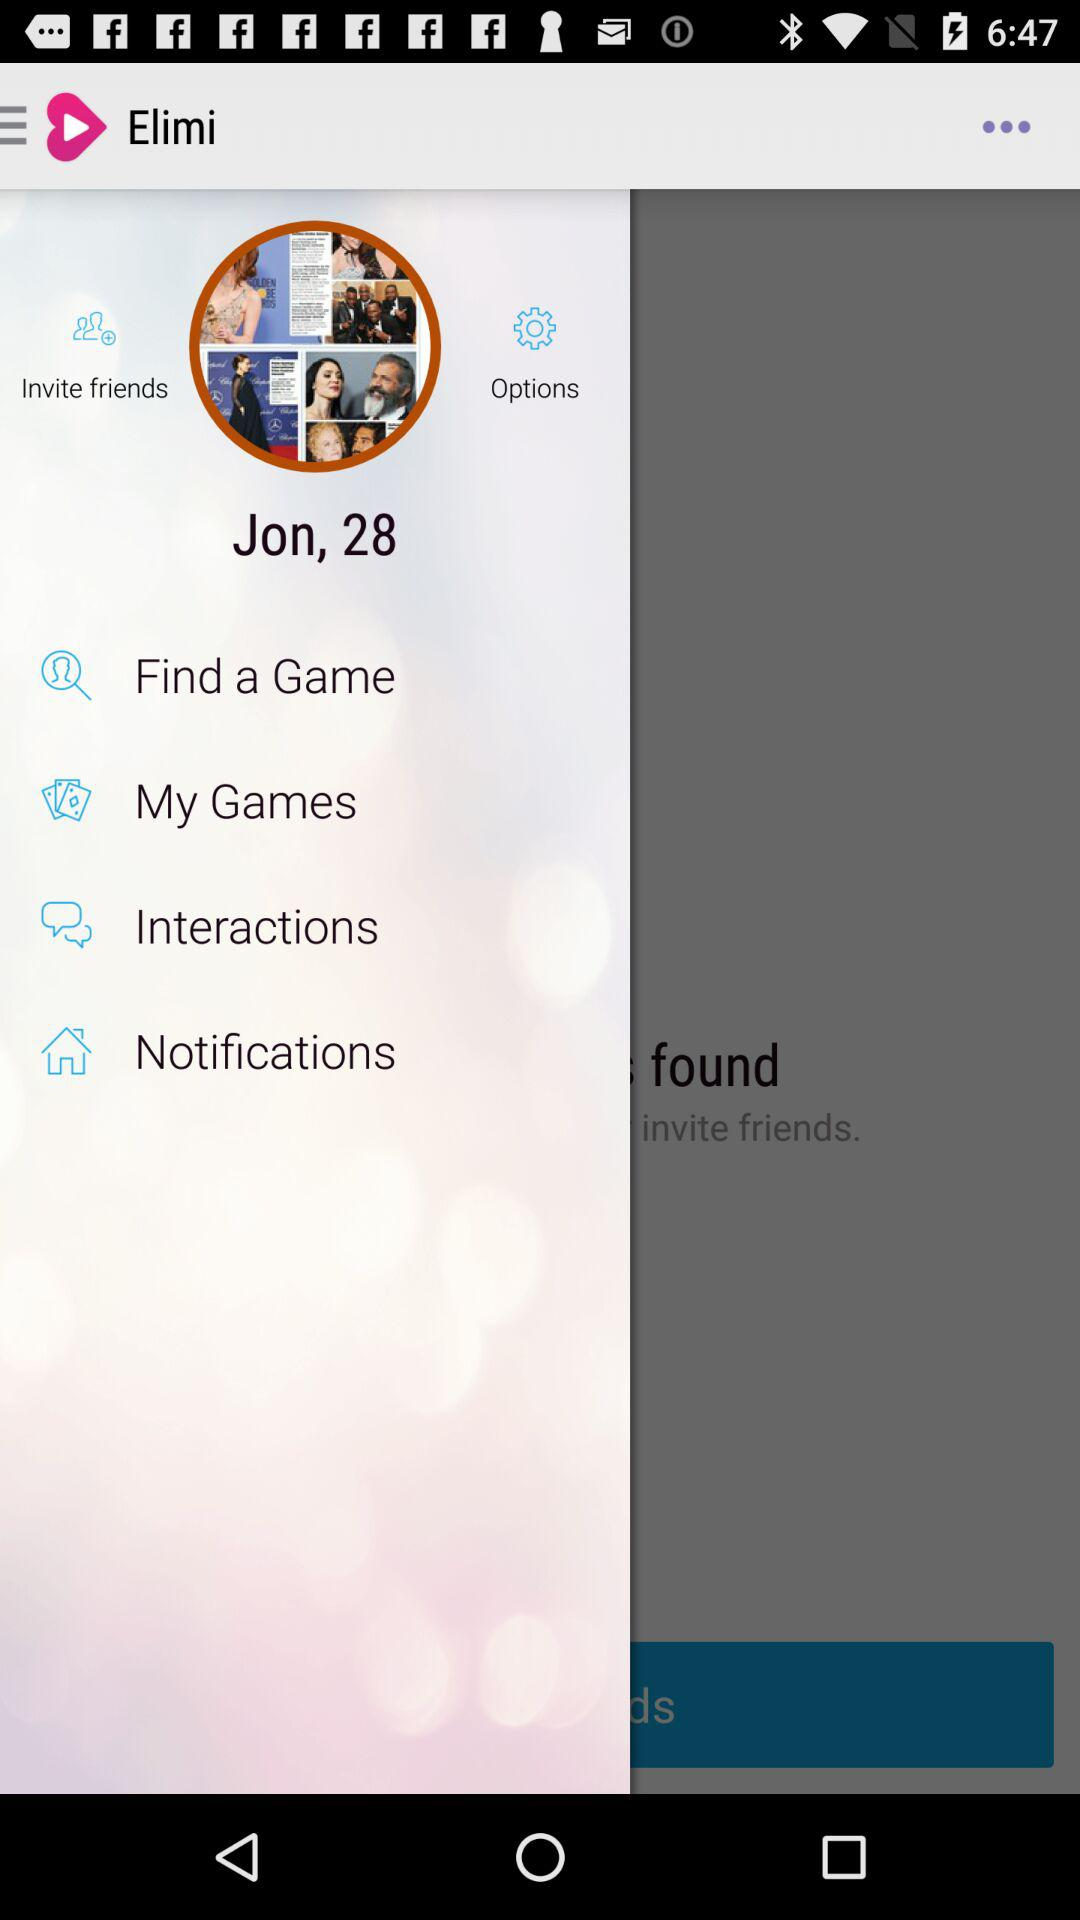What is the application name? The application name is "Elimi". 